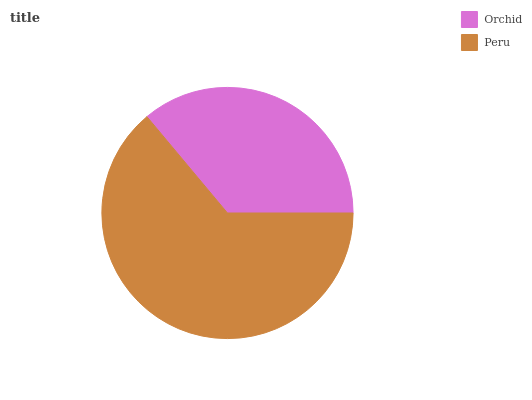Is Orchid the minimum?
Answer yes or no. Yes. Is Peru the maximum?
Answer yes or no. Yes. Is Peru the minimum?
Answer yes or no. No. Is Peru greater than Orchid?
Answer yes or no. Yes. Is Orchid less than Peru?
Answer yes or no. Yes. Is Orchid greater than Peru?
Answer yes or no. No. Is Peru less than Orchid?
Answer yes or no. No. Is Peru the high median?
Answer yes or no. Yes. Is Orchid the low median?
Answer yes or no. Yes. Is Orchid the high median?
Answer yes or no. No. Is Peru the low median?
Answer yes or no. No. 